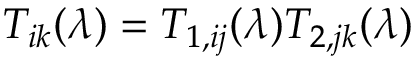<formula> <loc_0><loc_0><loc_500><loc_500>T _ { i k } ( \lambda ) = T _ { 1 , i j } ( \lambda ) T _ { 2 , j k } ( \lambda )</formula> 